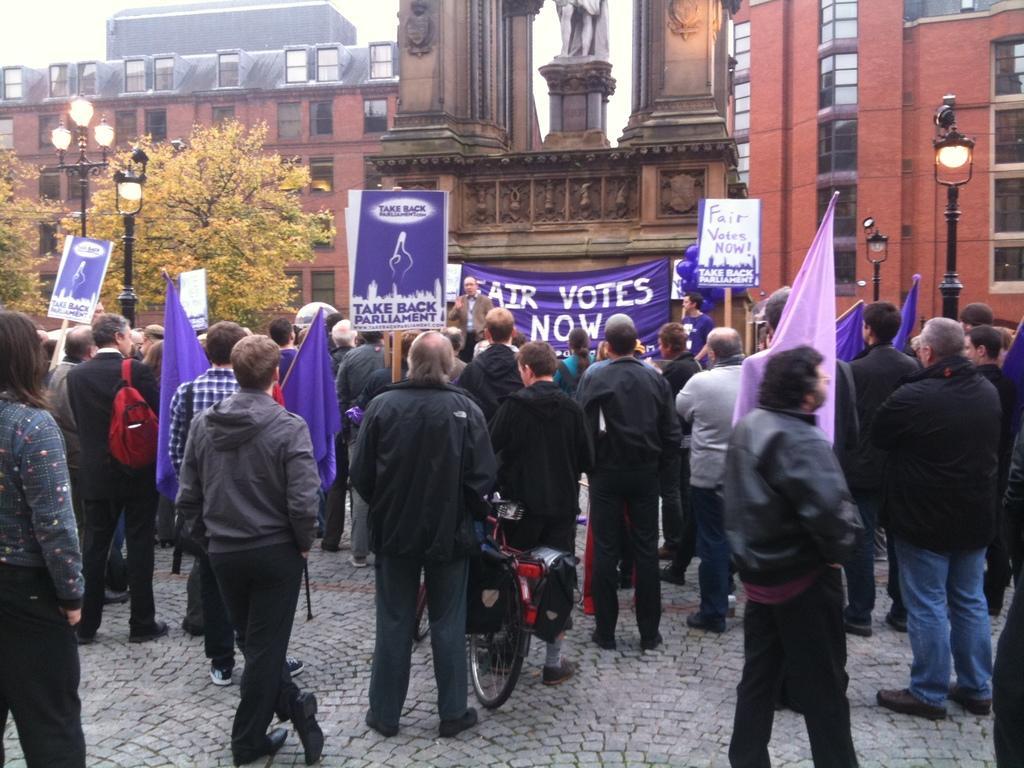Please provide a concise description of this image. In the foreground of the picture there are people holding flags, placards and banner. On the left there are trees and street lights. On the right there are street lights. In the background there is a building. 